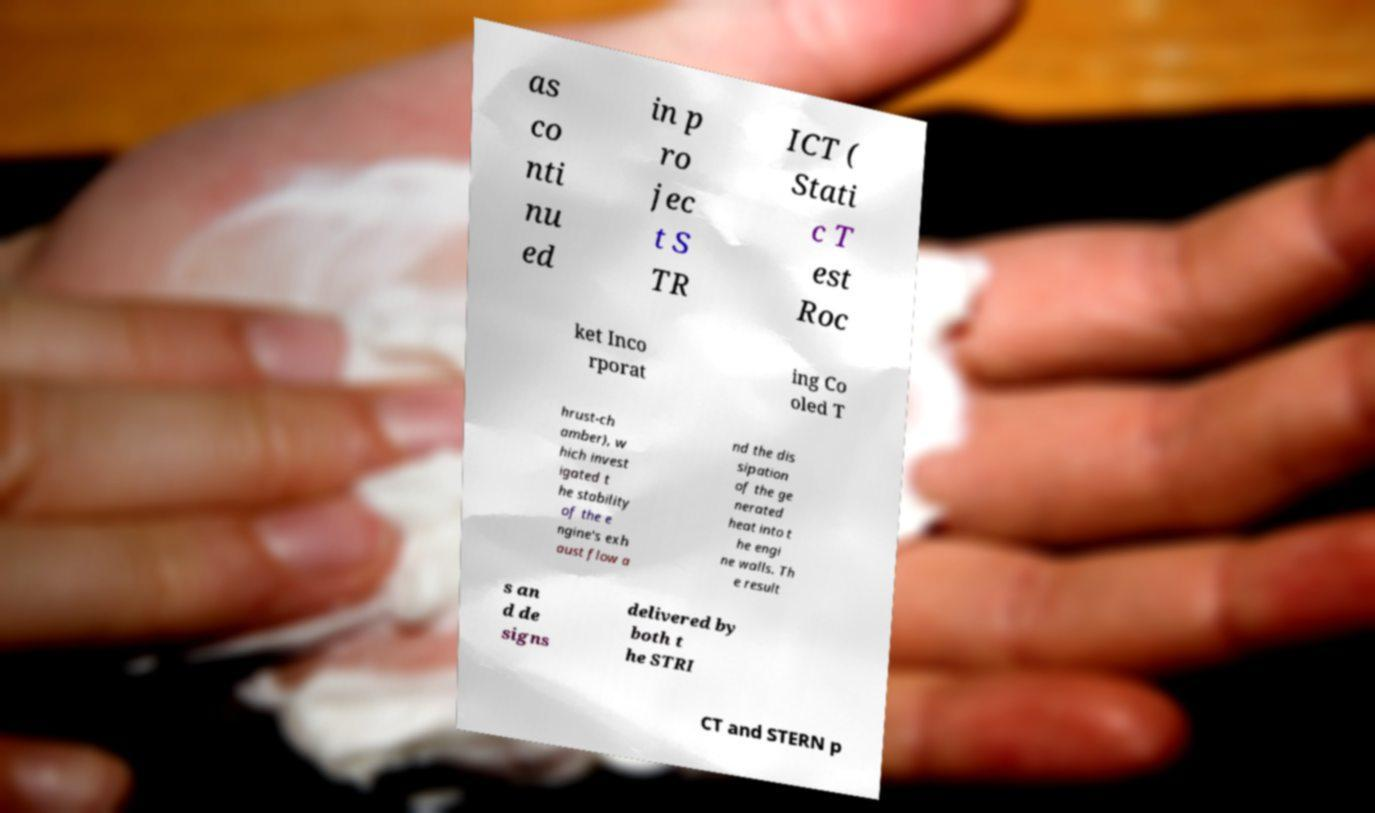I need the written content from this picture converted into text. Can you do that? as co nti nu ed in p ro jec t S TR ICT ( Stati c T est Roc ket Inco rporat ing Co oled T hrust-ch amber), w hich invest igated t he stability of the e ngine's exh aust flow a nd the dis sipation of the ge nerated heat into t he engi ne walls. Th e result s an d de signs delivered by both t he STRI CT and STERN p 